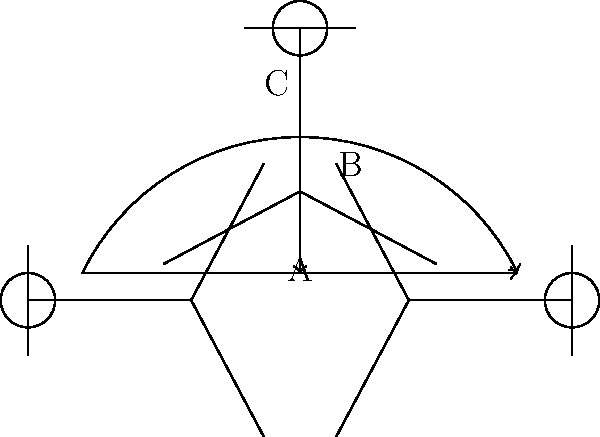As a netball coach, identify the types of passes illustrated by the stick figures in the diagram. Which pass is represented by line B? To identify the types of passes in netball, let's analyze each line in the diagram:

1. Line A: This is a straight horizontal line between two players at the same level. This represents a chest pass, which is a direct pass from one player to another at chest height.

2. Line B: This is a vertical line from a player at a higher position to a player at a lower position. This represents a lob pass or an overhead pass, where the ball is thrown in a high arc from one player to another.

3. Line C: This is a curved line between two players at the same level, with the curve going above the straight line connecting them. This represents a bounce pass, where the ball is bounced on the ground between the passer and the receiver.

Given the question asks specifically about line B, we can conclude that this vertical pass from a higher to a lower position is a lob pass or an overhead pass in netball terminology.
Answer: Lob pass (or Overhead pass) 